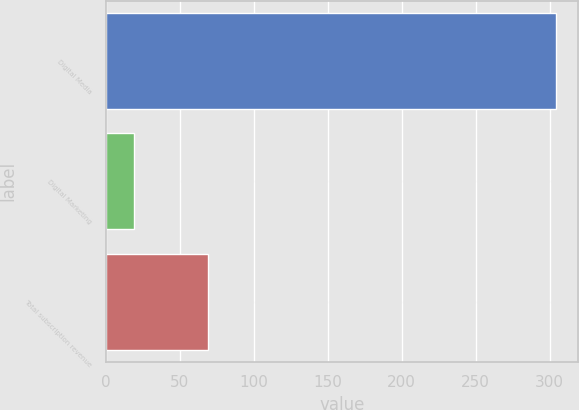<chart> <loc_0><loc_0><loc_500><loc_500><bar_chart><fcel>Digital Media<fcel>Digital Marketing<fcel>Total subscription revenue<nl><fcel>304<fcel>19<fcel>69<nl></chart> 